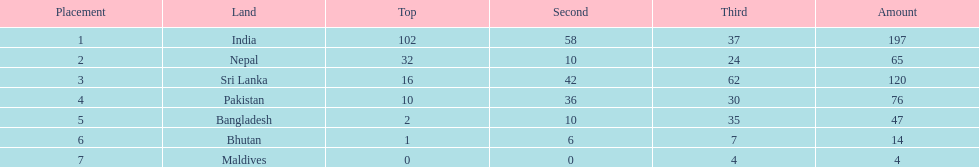What are the total number of bronze medals sri lanka have earned? 62. 